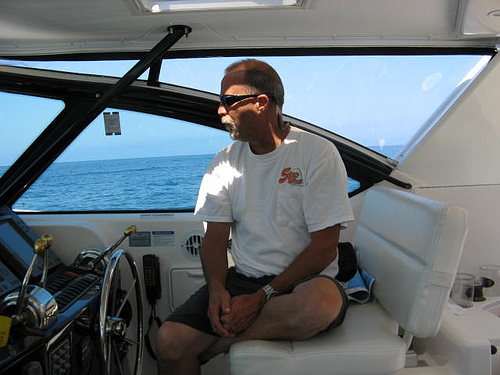<image>
Is the man on the couch? Yes. Looking at the image, I can see the man is positioned on top of the couch, with the couch providing support. 